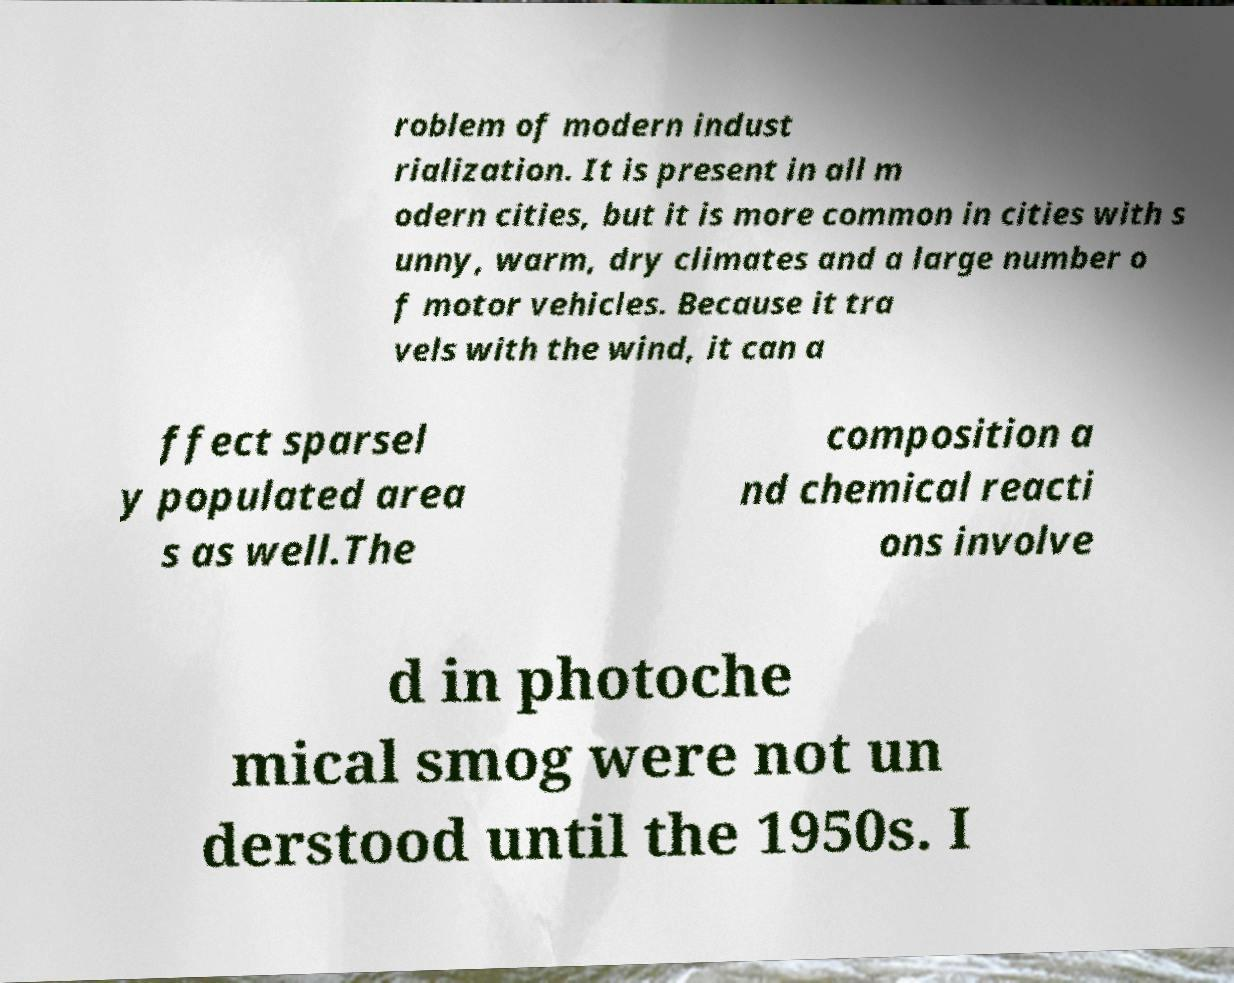Can you accurately transcribe the text from the provided image for me? roblem of modern indust rialization. It is present in all m odern cities, but it is more common in cities with s unny, warm, dry climates and a large number o f motor vehicles. Because it tra vels with the wind, it can a ffect sparsel y populated area s as well.The composition a nd chemical reacti ons involve d in photoche mical smog were not un derstood until the 1950s. I 